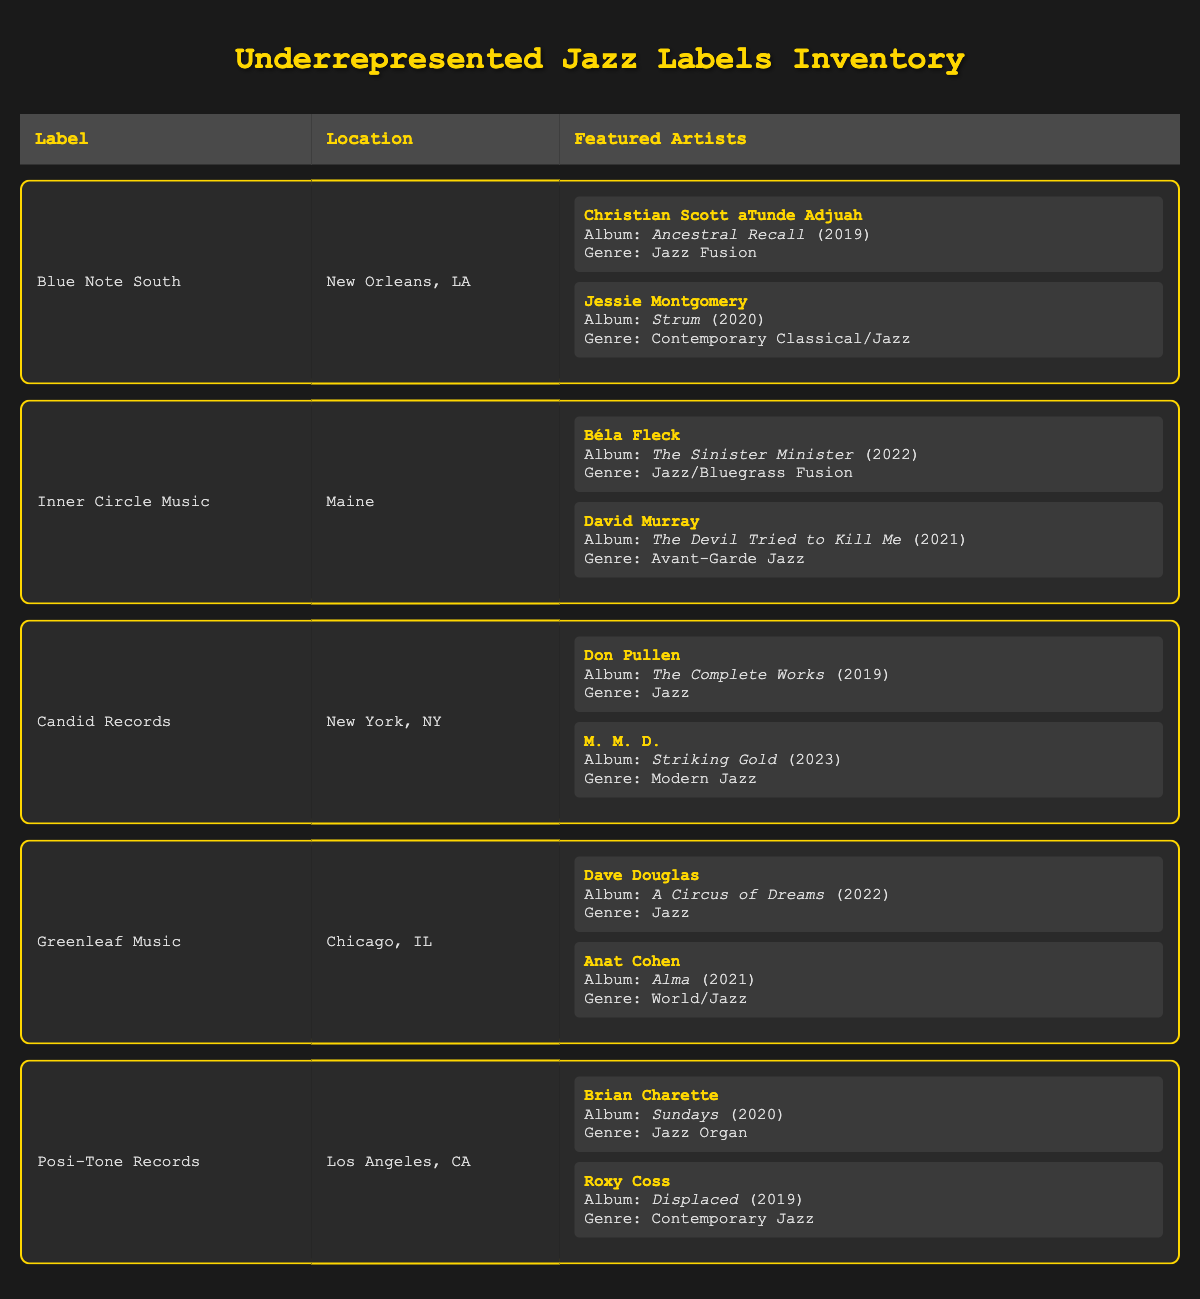What are the featured artists from Blue Note South? The table lists Blue Note South as having two featured artists: Christian Scott aTunde Adjuah with the album "Ancestral Recall" (2019) and Jessie Montgomery with the album "Strum" (2020).
Answer: Christian Scott aTunde Adjuah, Jessie Montgomery Which label is located in New York? The table shows that Candid Records is the label located in New York, NY.
Answer: Candid Records How many albums were released in 2021? The entries indicate that there are two albums released in 2021: David Murray's "The Devil Tried to Kill Me" from Inner Circle Music and Anat Cohen's "Alma" from Greenleaf Music. Thus, the total count is two.
Answer: 2 Is Jessie Montgomery featured on more than one album? By checking the table, Jessie Montgomery is featured on only one album, "Strum," released in 2020. Therefore, the statement is false.
Answer: No Which label has the most recent album listed in the inventory? The investigation reveals that both M. M. D.'s "Striking Gold" and Brian Charette's "Sundays" were released in 2023, but M. M. D. is featured under Candid Records. Therefore, it's Candid Records with the most recent album.
Answer: Candid Records 